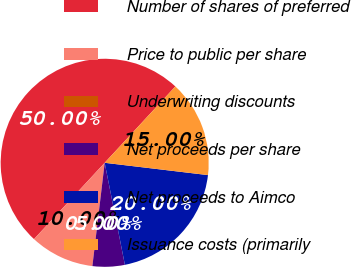Convert chart to OTSL. <chart><loc_0><loc_0><loc_500><loc_500><pie_chart><fcel>Number of shares of preferred<fcel>Price to public per share<fcel>Underwriting discounts<fcel>Net proceeds per share<fcel>Net proceeds to Aimco<fcel>Issuance costs (primarily<nl><fcel>50.0%<fcel>10.0%<fcel>0.0%<fcel>5.0%<fcel>20.0%<fcel>15.0%<nl></chart> 